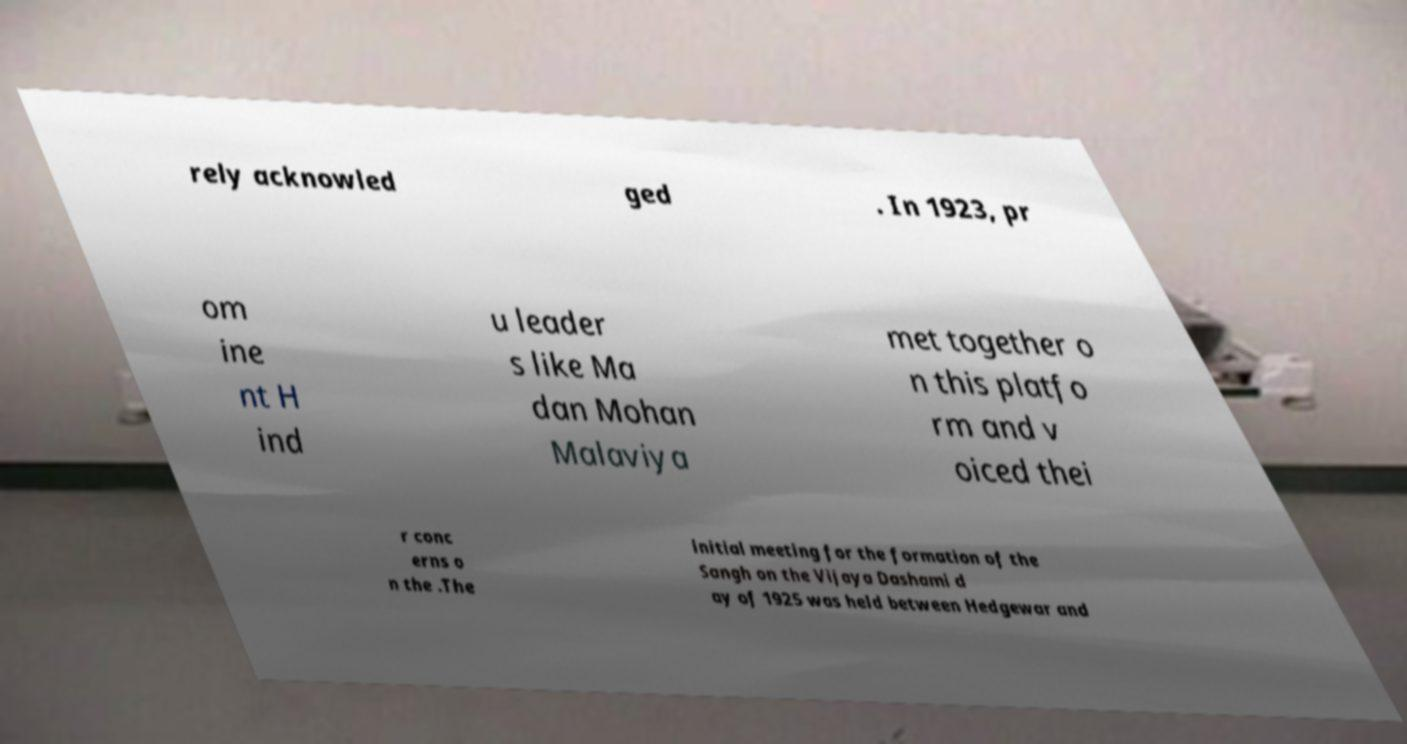I need the written content from this picture converted into text. Can you do that? rely acknowled ged . In 1923, pr om ine nt H ind u leader s like Ma dan Mohan Malaviya met together o n this platfo rm and v oiced thei r conc erns o n the .The initial meeting for the formation of the Sangh on the Vijaya Dashami d ay of 1925 was held between Hedgewar and 